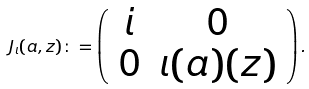Convert formula to latex. <formula><loc_0><loc_0><loc_500><loc_500>J _ { \iota } ( a , z ) \colon = \left ( \begin{array} { c c } i & 0 \\ 0 & \iota ( a ) ( z ) \end{array} \right ) .</formula> 